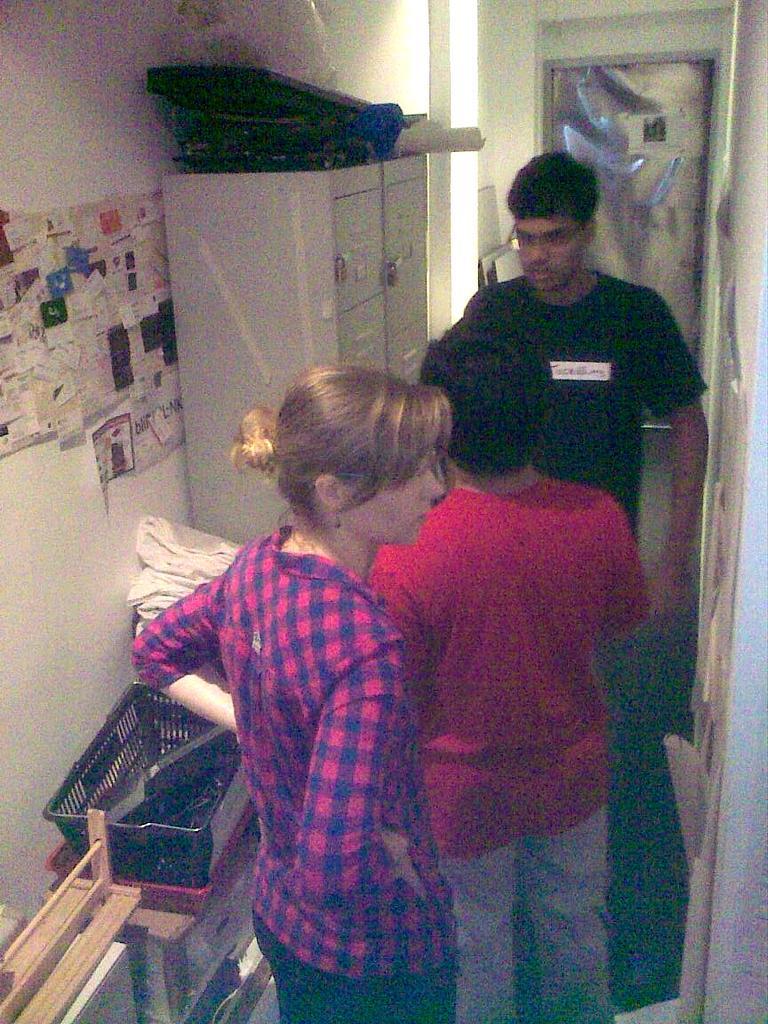Could you give a brief overview of what you see in this image? In this image we can see persons standing on the floor, papers pasted on the wall, storage containers, cupboard and some objects placed on it. 